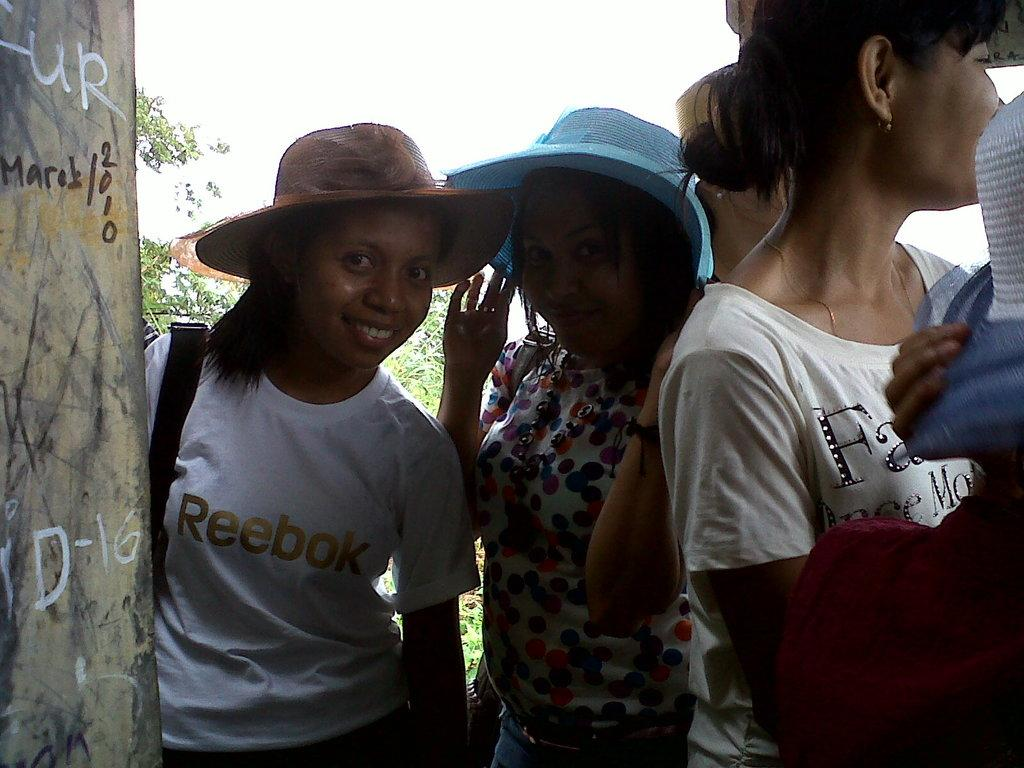What can be seen in the image? There are people standing in the image. What is located on the left side of the image? There is a pillar on the left side of the image. What type of vegetation is visible in the background of the image? There are plants visible in the background of the image. What color is the background of the image? The background of the image appears to be white. What type of feast is being prepared by the people in the image? There is no indication of a feast or any food preparation in the image. Can you see a bird perched on the pillar in the image? There is no bird visible in the image. 